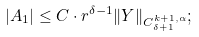<formula> <loc_0><loc_0><loc_500><loc_500>| A _ { 1 } | \leq C \cdot r ^ { \delta - 1 } \| Y \| _ { C ^ { k + 1 , \alpha } _ { \delta + 1 } } ;</formula> 